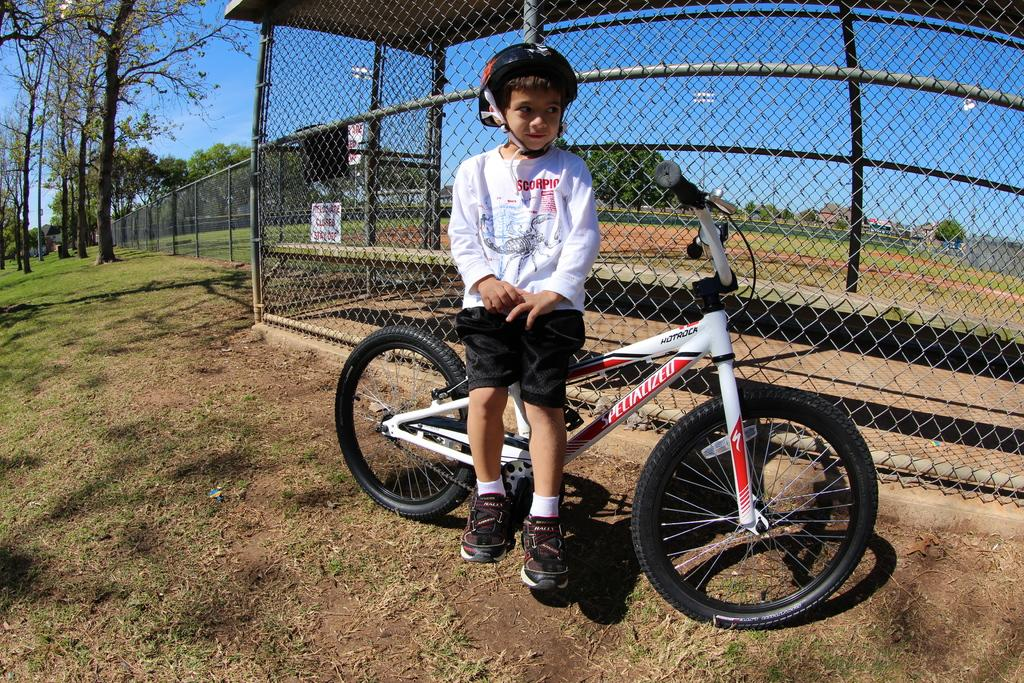Who is the main subject in the image? There is a boy in the image. What is the boy doing in the image? The boy is riding a bicycle. What type of surface is the boy riding on? The ground is covered with grass. What is beside the boy while he is riding the bicycle? There is railing beside the boy. How many cents can be seen in the image? There are no cents present in the image. What type of form is the boy holding while riding the bicycle? The boy is not holding any form while riding the bicycle. 